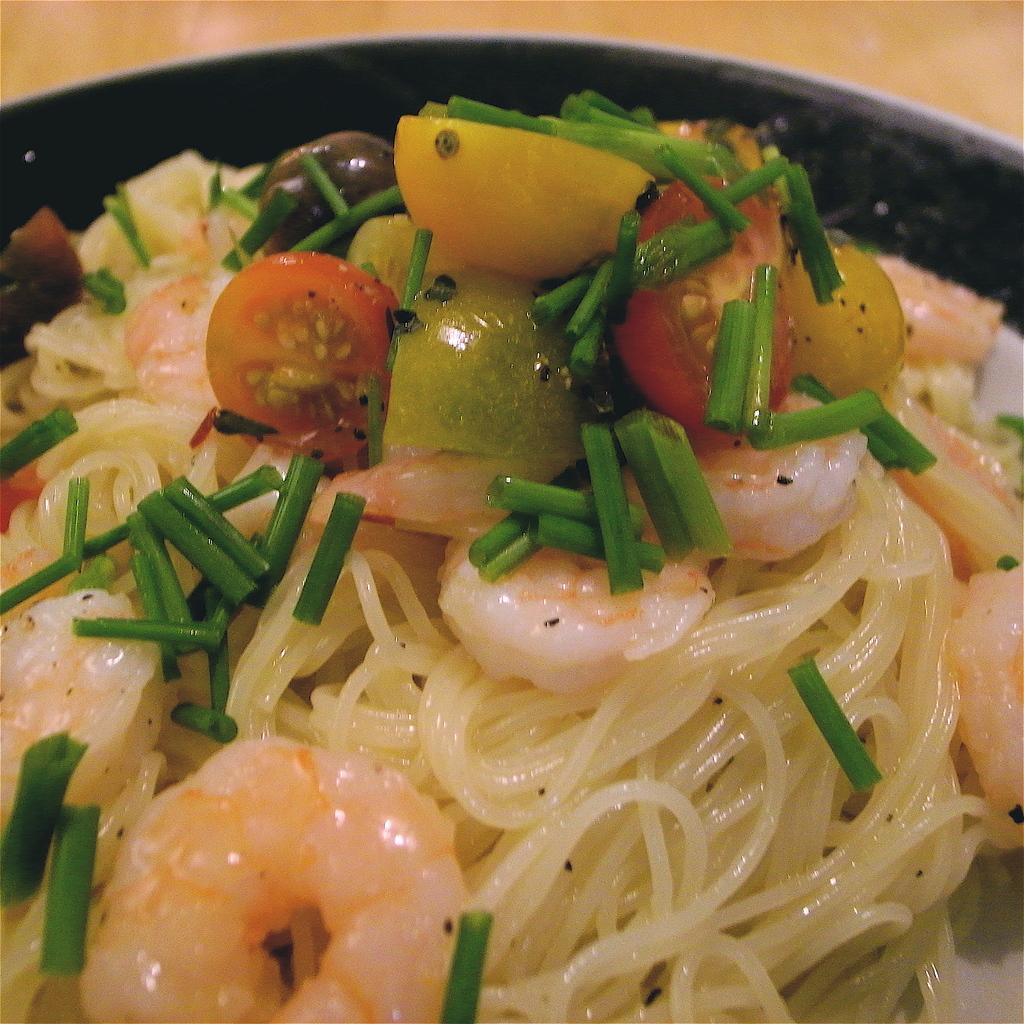Can you describe this image briefly? In this picture we can see food. 